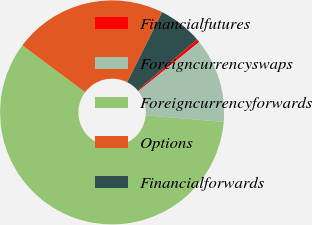<chart> <loc_0><loc_0><loc_500><loc_500><pie_chart><fcel>Financialfutures<fcel>Foreigncurrencyswaps<fcel>Foreigncurrencyforwards<fcel>Options<fcel>Financialforwards<nl><fcel>0.49%<fcel>12.16%<fcel>58.85%<fcel>22.16%<fcel>6.33%<nl></chart> 